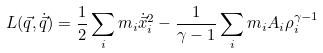<formula> <loc_0><loc_0><loc_500><loc_500>L ( { \vec { q } } , \dot { \vec { q } } ) = \frac { 1 } { 2 } \sum _ { i } m _ { i } \dot { \vec { x } } _ { i } ^ { 2 } - \frac { 1 } { \gamma - 1 } \sum _ { i } m _ { i } A _ { i } \rho _ { i } ^ { \gamma - 1 }</formula> 